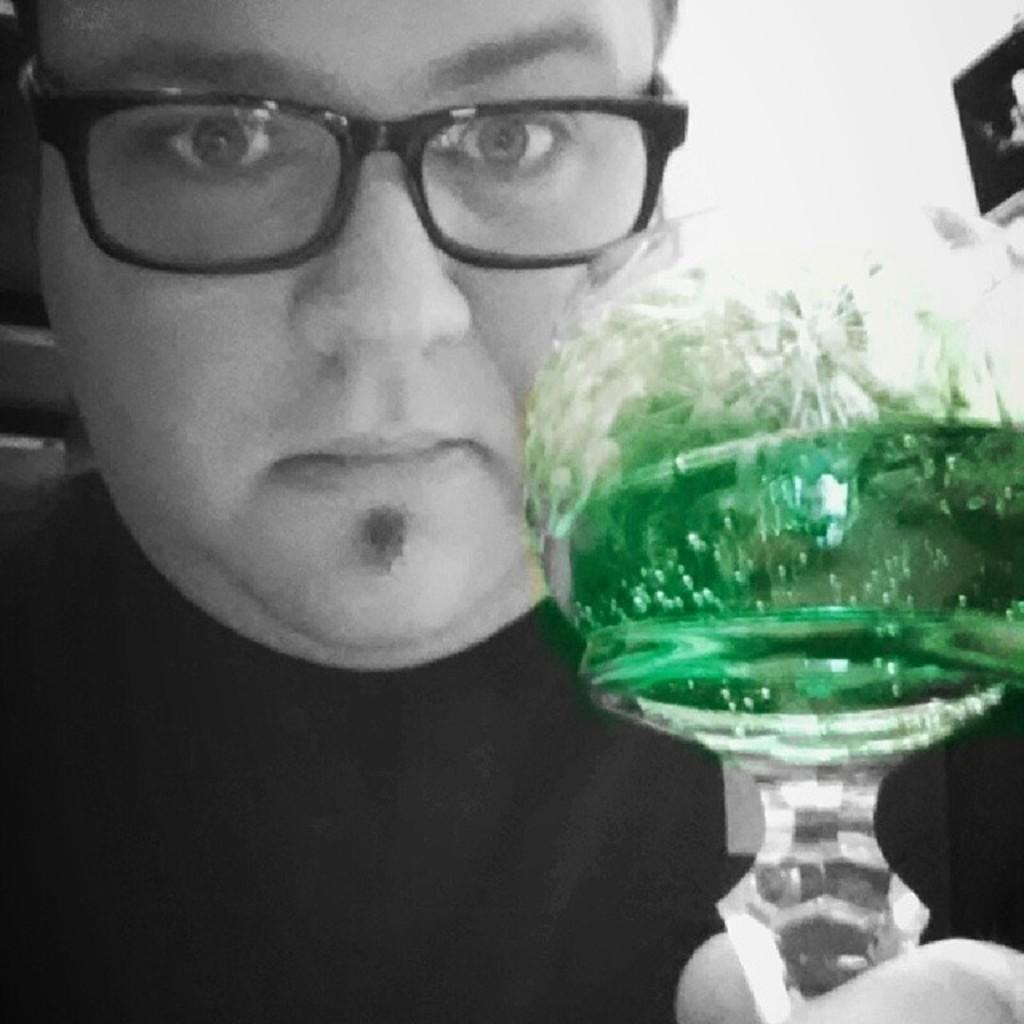What is the main subject of the image? The main subject of the image is a man. What can be observed about the man's appearance? The man is wearing specs. Can you describe the background of the image? The background of the image is blurred. What type of fowl can be seen in the image? There is no fowl present in the image. How many cattle are visible in the image? There are no cattle present in the image. What book is the man holding in the image? There is no book visible in the image. 